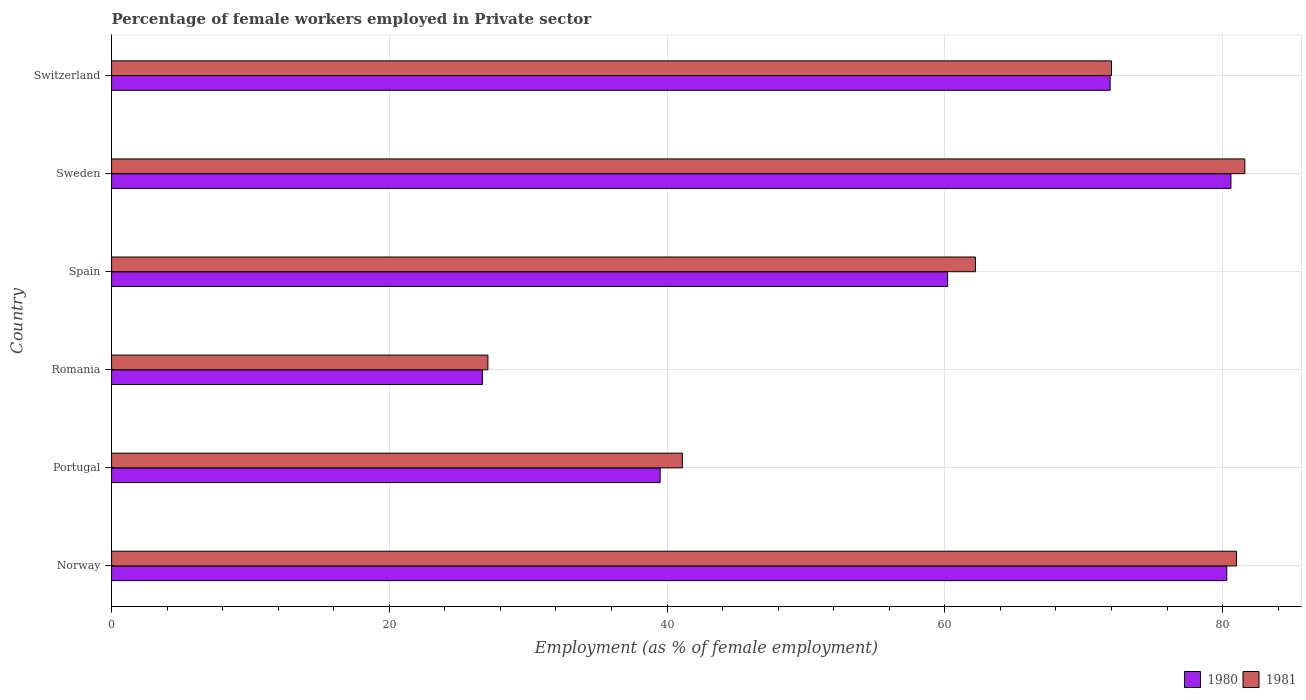How many different coloured bars are there?
Make the answer very short. 2. Are the number of bars per tick equal to the number of legend labels?
Make the answer very short. Yes. What is the label of the 6th group of bars from the top?
Offer a very short reply. Norway. In how many cases, is the number of bars for a given country not equal to the number of legend labels?
Give a very brief answer. 0. What is the percentage of females employed in Private sector in 1980 in Norway?
Offer a very short reply. 80.3. Across all countries, what is the maximum percentage of females employed in Private sector in 1981?
Offer a very short reply. 81.6. Across all countries, what is the minimum percentage of females employed in Private sector in 1981?
Provide a short and direct response. 27.1. In which country was the percentage of females employed in Private sector in 1981 minimum?
Your answer should be very brief. Romania. What is the total percentage of females employed in Private sector in 1980 in the graph?
Ensure brevity in your answer.  359.2. What is the difference between the percentage of females employed in Private sector in 1980 in Norway and that in Sweden?
Keep it short and to the point. -0.3. What is the difference between the percentage of females employed in Private sector in 1981 in Romania and the percentage of females employed in Private sector in 1980 in Sweden?
Your answer should be very brief. -53.5. What is the average percentage of females employed in Private sector in 1980 per country?
Your answer should be very brief. 59.87. What is the difference between the percentage of females employed in Private sector in 1980 and percentage of females employed in Private sector in 1981 in Norway?
Make the answer very short. -0.7. What is the ratio of the percentage of females employed in Private sector in 1981 in Norway to that in Switzerland?
Keep it short and to the point. 1.12. What is the difference between the highest and the second highest percentage of females employed in Private sector in 1980?
Give a very brief answer. 0.3. What is the difference between the highest and the lowest percentage of females employed in Private sector in 1981?
Your answer should be very brief. 54.5. Is the sum of the percentage of females employed in Private sector in 1980 in Norway and Spain greater than the maximum percentage of females employed in Private sector in 1981 across all countries?
Offer a terse response. Yes. What does the 1st bar from the top in Portugal represents?
Give a very brief answer. 1981. Are all the bars in the graph horizontal?
Provide a short and direct response. Yes. How many countries are there in the graph?
Give a very brief answer. 6. What is the difference between two consecutive major ticks on the X-axis?
Your answer should be compact. 20. Does the graph contain any zero values?
Offer a terse response. No. Does the graph contain grids?
Make the answer very short. Yes. Where does the legend appear in the graph?
Your answer should be compact. Bottom right. How many legend labels are there?
Give a very brief answer. 2. How are the legend labels stacked?
Keep it short and to the point. Horizontal. What is the title of the graph?
Provide a short and direct response. Percentage of female workers employed in Private sector. Does "1990" appear as one of the legend labels in the graph?
Keep it short and to the point. No. What is the label or title of the X-axis?
Your answer should be compact. Employment (as % of female employment). What is the Employment (as % of female employment) of 1980 in Norway?
Offer a very short reply. 80.3. What is the Employment (as % of female employment) of 1981 in Norway?
Offer a very short reply. 81. What is the Employment (as % of female employment) of 1980 in Portugal?
Give a very brief answer. 39.5. What is the Employment (as % of female employment) of 1981 in Portugal?
Keep it short and to the point. 41.1. What is the Employment (as % of female employment) in 1980 in Romania?
Your answer should be compact. 26.7. What is the Employment (as % of female employment) in 1981 in Romania?
Keep it short and to the point. 27.1. What is the Employment (as % of female employment) in 1980 in Spain?
Offer a terse response. 60.2. What is the Employment (as % of female employment) in 1981 in Spain?
Give a very brief answer. 62.2. What is the Employment (as % of female employment) in 1980 in Sweden?
Your answer should be compact. 80.6. What is the Employment (as % of female employment) of 1981 in Sweden?
Provide a succinct answer. 81.6. What is the Employment (as % of female employment) in 1980 in Switzerland?
Provide a short and direct response. 71.9. What is the Employment (as % of female employment) in 1981 in Switzerland?
Offer a very short reply. 72. Across all countries, what is the maximum Employment (as % of female employment) in 1980?
Keep it short and to the point. 80.6. Across all countries, what is the maximum Employment (as % of female employment) in 1981?
Offer a very short reply. 81.6. Across all countries, what is the minimum Employment (as % of female employment) in 1980?
Offer a very short reply. 26.7. Across all countries, what is the minimum Employment (as % of female employment) of 1981?
Provide a succinct answer. 27.1. What is the total Employment (as % of female employment) of 1980 in the graph?
Provide a succinct answer. 359.2. What is the total Employment (as % of female employment) of 1981 in the graph?
Your answer should be very brief. 365. What is the difference between the Employment (as % of female employment) of 1980 in Norway and that in Portugal?
Offer a terse response. 40.8. What is the difference between the Employment (as % of female employment) of 1981 in Norway and that in Portugal?
Offer a very short reply. 39.9. What is the difference between the Employment (as % of female employment) of 1980 in Norway and that in Romania?
Make the answer very short. 53.6. What is the difference between the Employment (as % of female employment) in 1981 in Norway and that in Romania?
Your answer should be compact. 53.9. What is the difference between the Employment (as % of female employment) of 1980 in Norway and that in Spain?
Keep it short and to the point. 20.1. What is the difference between the Employment (as % of female employment) in 1981 in Norway and that in Spain?
Give a very brief answer. 18.8. What is the difference between the Employment (as % of female employment) in 1980 in Portugal and that in Spain?
Your answer should be very brief. -20.7. What is the difference between the Employment (as % of female employment) of 1981 in Portugal and that in Spain?
Your answer should be compact. -21.1. What is the difference between the Employment (as % of female employment) of 1980 in Portugal and that in Sweden?
Provide a short and direct response. -41.1. What is the difference between the Employment (as % of female employment) in 1981 in Portugal and that in Sweden?
Ensure brevity in your answer.  -40.5. What is the difference between the Employment (as % of female employment) of 1980 in Portugal and that in Switzerland?
Give a very brief answer. -32.4. What is the difference between the Employment (as % of female employment) in 1981 in Portugal and that in Switzerland?
Provide a short and direct response. -30.9. What is the difference between the Employment (as % of female employment) in 1980 in Romania and that in Spain?
Your answer should be very brief. -33.5. What is the difference between the Employment (as % of female employment) of 1981 in Romania and that in Spain?
Provide a short and direct response. -35.1. What is the difference between the Employment (as % of female employment) in 1980 in Romania and that in Sweden?
Ensure brevity in your answer.  -53.9. What is the difference between the Employment (as % of female employment) in 1981 in Romania and that in Sweden?
Offer a terse response. -54.5. What is the difference between the Employment (as % of female employment) of 1980 in Romania and that in Switzerland?
Provide a succinct answer. -45.2. What is the difference between the Employment (as % of female employment) in 1981 in Romania and that in Switzerland?
Keep it short and to the point. -44.9. What is the difference between the Employment (as % of female employment) of 1980 in Spain and that in Sweden?
Offer a very short reply. -20.4. What is the difference between the Employment (as % of female employment) in 1981 in Spain and that in Sweden?
Keep it short and to the point. -19.4. What is the difference between the Employment (as % of female employment) in 1980 in Spain and that in Switzerland?
Provide a short and direct response. -11.7. What is the difference between the Employment (as % of female employment) in 1981 in Spain and that in Switzerland?
Your response must be concise. -9.8. What is the difference between the Employment (as % of female employment) of 1980 in Norway and the Employment (as % of female employment) of 1981 in Portugal?
Give a very brief answer. 39.2. What is the difference between the Employment (as % of female employment) of 1980 in Norway and the Employment (as % of female employment) of 1981 in Romania?
Your answer should be very brief. 53.2. What is the difference between the Employment (as % of female employment) of 1980 in Norway and the Employment (as % of female employment) of 1981 in Switzerland?
Give a very brief answer. 8.3. What is the difference between the Employment (as % of female employment) in 1980 in Portugal and the Employment (as % of female employment) in 1981 in Romania?
Provide a succinct answer. 12.4. What is the difference between the Employment (as % of female employment) of 1980 in Portugal and the Employment (as % of female employment) of 1981 in Spain?
Keep it short and to the point. -22.7. What is the difference between the Employment (as % of female employment) of 1980 in Portugal and the Employment (as % of female employment) of 1981 in Sweden?
Keep it short and to the point. -42.1. What is the difference between the Employment (as % of female employment) of 1980 in Portugal and the Employment (as % of female employment) of 1981 in Switzerland?
Provide a short and direct response. -32.5. What is the difference between the Employment (as % of female employment) of 1980 in Romania and the Employment (as % of female employment) of 1981 in Spain?
Offer a terse response. -35.5. What is the difference between the Employment (as % of female employment) in 1980 in Romania and the Employment (as % of female employment) in 1981 in Sweden?
Your response must be concise. -54.9. What is the difference between the Employment (as % of female employment) of 1980 in Romania and the Employment (as % of female employment) of 1981 in Switzerland?
Your answer should be compact. -45.3. What is the difference between the Employment (as % of female employment) of 1980 in Spain and the Employment (as % of female employment) of 1981 in Sweden?
Your answer should be very brief. -21.4. What is the difference between the Employment (as % of female employment) in 1980 in Sweden and the Employment (as % of female employment) in 1981 in Switzerland?
Ensure brevity in your answer.  8.6. What is the average Employment (as % of female employment) in 1980 per country?
Provide a succinct answer. 59.87. What is the average Employment (as % of female employment) of 1981 per country?
Offer a very short reply. 60.83. What is the difference between the Employment (as % of female employment) of 1980 and Employment (as % of female employment) of 1981 in Norway?
Your response must be concise. -0.7. What is the difference between the Employment (as % of female employment) in 1980 and Employment (as % of female employment) in 1981 in Romania?
Make the answer very short. -0.4. What is the difference between the Employment (as % of female employment) of 1980 and Employment (as % of female employment) of 1981 in Spain?
Keep it short and to the point. -2. What is the ratio of the Employment (as % of female employment) in 1980 in Norway to that in Portugal?
Your response must be concise. 2.03. What is the ratio of the Employment (as % of female employment) in 1981 in Norway to that in Portugal?
Make the answer very short. 1.97. What is the ratio of the Employment (as % of female employment) of 1980 in Norway to that in Romania?
Ensure brevity in your answer.  3.01. What is the ratio of the Employment (as % of female employment) in 1981 in Norway to that in Romania?
Offer a very short reply. 2.99. What is the ratio of the Employment (as % of female employment) of 1980 in Norway to that in Spain?
Your answer should be very brief. 1.33. What is the ratio of the Employment (as % of female employment) of 1981 in Norway to that in Spain?
Your answer should be compact. 1.3. What is the ratio of the Employment (as % of female employment) in 1981 in Norway to that in Sweden?
Provide a succinct answer. 0.99. What is the ratio of the Employment (as % of female employment) of 1980 in Norway to that in Switzerland?
Provide a short and direct response. 1.12. What is the ratio of the Employment (as % of female employment) in 1981 in Norway to that in Switzerland?
Your answer should be compact. 1.12. What is the ratio of the Employment (as % of female employment) in 1980 in Portugal to that in Romania?
Your answer should be compact. 1.48. What is the ratio of the Employment (as % of female employment) of 1981 in Portugal to that in Romania?
Your answer should be compact. 1.52. What is the ratio of the Employment (as % of female employment) in 1980 in Portugal to that in Spain?
Your answer should be compact. 0.66. What is the ratio of the Employment (as % of female employment) in 1981 in Portugal to that in Spain?
Make the answer very short. 0.66. What is the ratio of the Employment (as % of female employment) of 1980 in Portugal to that in Sweden?
Keep it short and to the point. 0.49. What is the ratio of the Employment (as % of female employment) in 1981 in Portugal to that in Sweden?
Your response must be concise. 0.5. What is the ratio of the Employment (as % of female employment) of 1980 in Portugal to that in Switzerland?
Provide a succinct answer. 0.55. What is the ratio of the Employment (as % of female employment) of 1981 in Portugal to that in Switzerland?
Provide a succinct answer. 0.57. What is the ratio of the Employment (as % of female employment) in 1980 in Romania to that in Spain?
Provide a short and direct response. 0.44. What is the ratio of the Employment (as % of female employment) in 1981 in Romania to that in Spain?
Keep it short and to the point. 0.44. What is the ratio of the Employment (as % of female employment) in 1980 in Romania to that in Sweden?
Provide a short and direct response. 0.33. What is the ratio of the Employment (as % of female employment) of 1981 in Romania to that in Sweden?
Provide a succinct answer. 0.33. What is the ratio of the Employment (as % of female employment) in 1980 in Romania to that in Switzerland?
Offer a very short reply. 0.37. What is the ratio of the Employment (as % of female employment) of 1981 in Romania to that in Switzerland?
Give a very brief answer. 0.38. What is the ratio of the Employment (as % of female employment) in 1980 in Spain to that in Sweden?
Make the answer very short. 0.75. What is the ratio of the Employment (as % of female employment) of 1981 in Spain to that in Sweden?
Your response must be concise. 0.76. What is the ratio of the Employment (as % of female employment) in 1980 in Spain to that in Switzerland?
Provide a short and direct response. 0.84. What is the ratio of the Employment (as % of female employment) in 1981 in Spain to that in Switzerland?
Provide a succinct answer. 0.86. What is the ratio of the Employment (as % of female employment) of 1980 in Sweden to that in Switzerland?
Give a very brief answer. 1.12. What is the ratio of the Employment (as % of female employment) in 1981 in Sweden to that in Switzerland?
Ensure brevity in your answer.  1.13. What is the difference between the highest and the second highest Employment (as % of female employment) in 1980?
Make the answer very short. 0.3. What is the difference between the highest and the lowest Employment (as % of female employment) of 1980?
Your response must be concise. 53.9. What is the difference between the highest and the lowest Employment (as % of female employment) in 1981?
Provide a succinct answer. 54.5. 